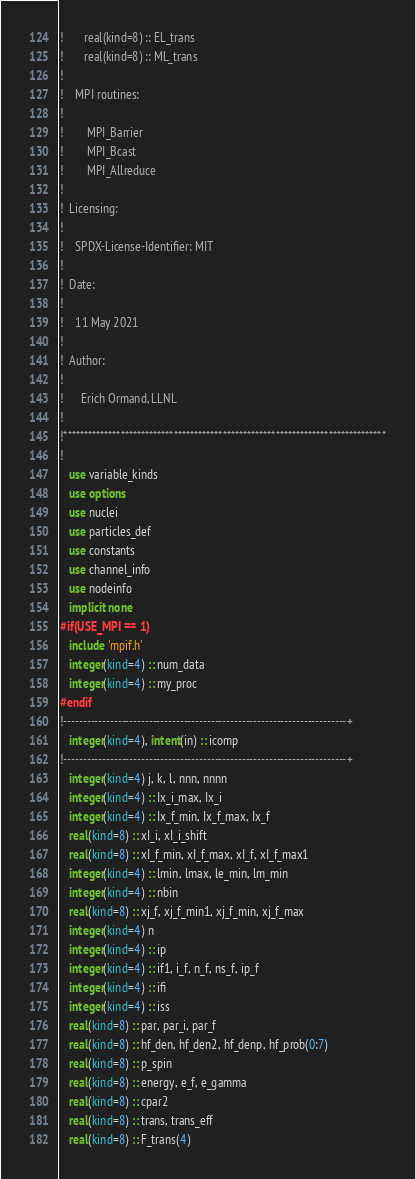Convert code to text. <code><loc_0><loc_0><loc_500><loc_500><_FORTRAN_>!       real(kind=8) :: EL_trans
!       real(kind=8) :: ML_trans
!
!    MPI routines:
!
!        MPI_Barrier
!        MPI_Bcast
!        MPI_Allreduce
!
!  Licensing:
!
!    SPDX-License-Identifier: MIT 
!
!  Date:
!
!    11 May 2021
!
!  Author:
!
!      Erich Ormand, LLNL
!
!*******************************************************************************
!
   use variable_kinds
   use options
   use nuclei
   use particles_def
   use constants 
   use channel_info
   use nodeinfo
   implicit none
#if(USE_MPI == 1)
   include 'mpif.h'
   integer(kind=4) :: num_data
   integer(kind=4) :: my_proc
#endif
!-------------------------------------------------------------------------+
   integer(kind=4), intent(in) :: icomp
!-------------------------------------------------------------------------+
   integer(kind=4) j, k, l, nnn, nnnn
   integer(kind=4) :: Ix_i_max, Ix_i
   integer(kind=4) :: Ix_f_min, Ix_f_max, Ix_f
   real(kind=8) :: xI_i, xI_i_shift
   real(kind=8) :: xI_f_min, xI_f_max, xI_f, xI_f_max1
   integer(kind=4) :: lmin, lmax, le_min, lm_min
   integer(kind=4) :: nbin
   real(kind=8) :: xj_f, xj_f_min1, xj_f_min, xj_f_max
   integer(kind=4) n
   integer(kind=4) :: ip
   integer(kind=4) :: if1, i_f, n_f, ns_f, ip_f
   integer(kind=4) :: ifi
   integer(kind=4) :: iss
   real(kind=8) :: par, par_i, par_f
   real(kind=8) :: hf_den, hf_den2, hf_denp, hf_prob(0:7)
   real(kind=8) :: p_spin
   real(kind=8) :: energy, e_f, e_gamma
   real(kind=8) :: cpar2
   real(kind=8) :: trans, trans_eff
   real(kind=8) :: F_trans(4)
</code> 